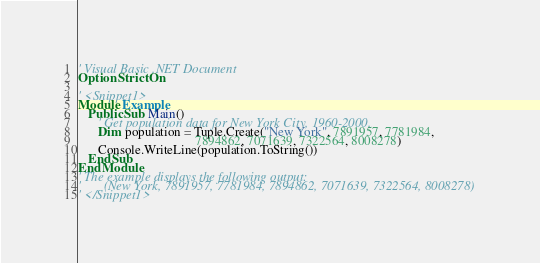Convert code to text. <code><loc_0><loc_0><loc_500><loc_500><_VisualBasic_>' Visual Basic .NET Document
Option Strict On

' <Snippet1>
Module Example
   Public Sub Main()
      ' Get population data for New York City, 1960-2000.
      Dim population = Tuple.Create("New York", 7891957, 7781984, 
                                    7894862, 7071639, 7322564, 8008278)
      Console.WriteLine(population.ToString())                                 
   End Sub
End Module
' The example displays the following output:
'       (New York, 7891957, 7781984, 7894862, 7071639, 7322564, 8008278)
' </Snippet1>
</code> 